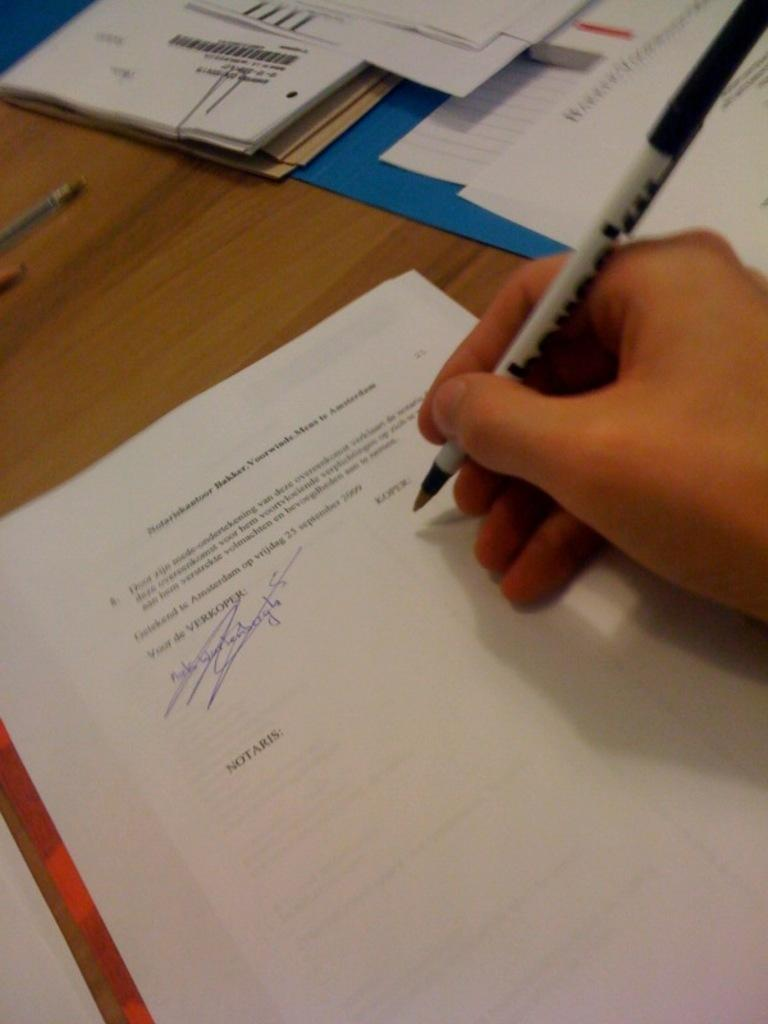What is the person's hand holding in the image? The person's hand is holding a pen in the image. What is the surface on which the papers and files are placed? The papers and files are placed on a wooden table. What else can be seen on the wooden table besides papers and files? There are a few more unspecified items on the wooden table. Can you see any signs of a crime happening in the image? There is no indication of a crime in the image; it shows a person's hand holding a pen and items on a wooden table. 